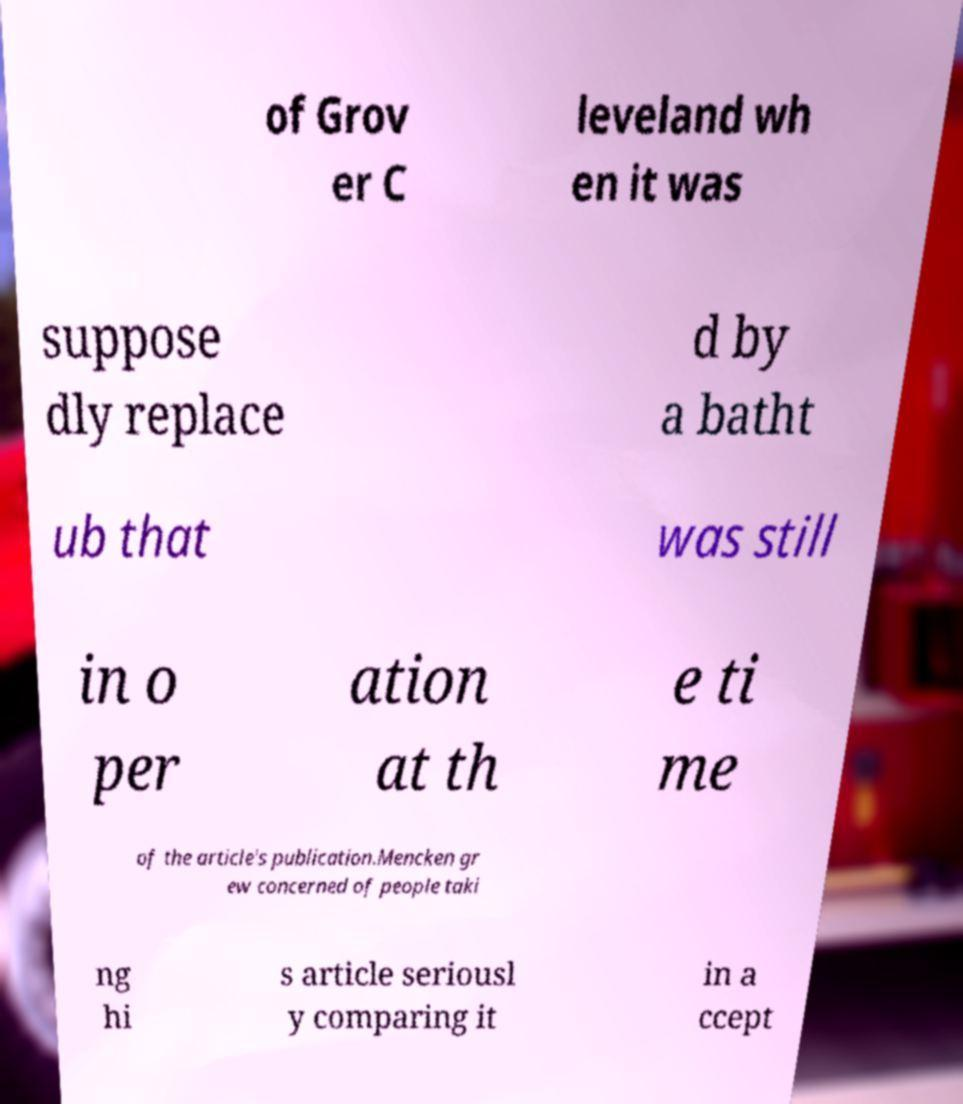Please read and relay the text visible in this image. What does it say? of Grov er C leveland wh en it was suppose dly replace d by a batht ub that was still in o per ation at th e ti me of the article's publication.Mencken gr ew concerned of people taki ng hi s article seriousl y comparing it in a ccept 